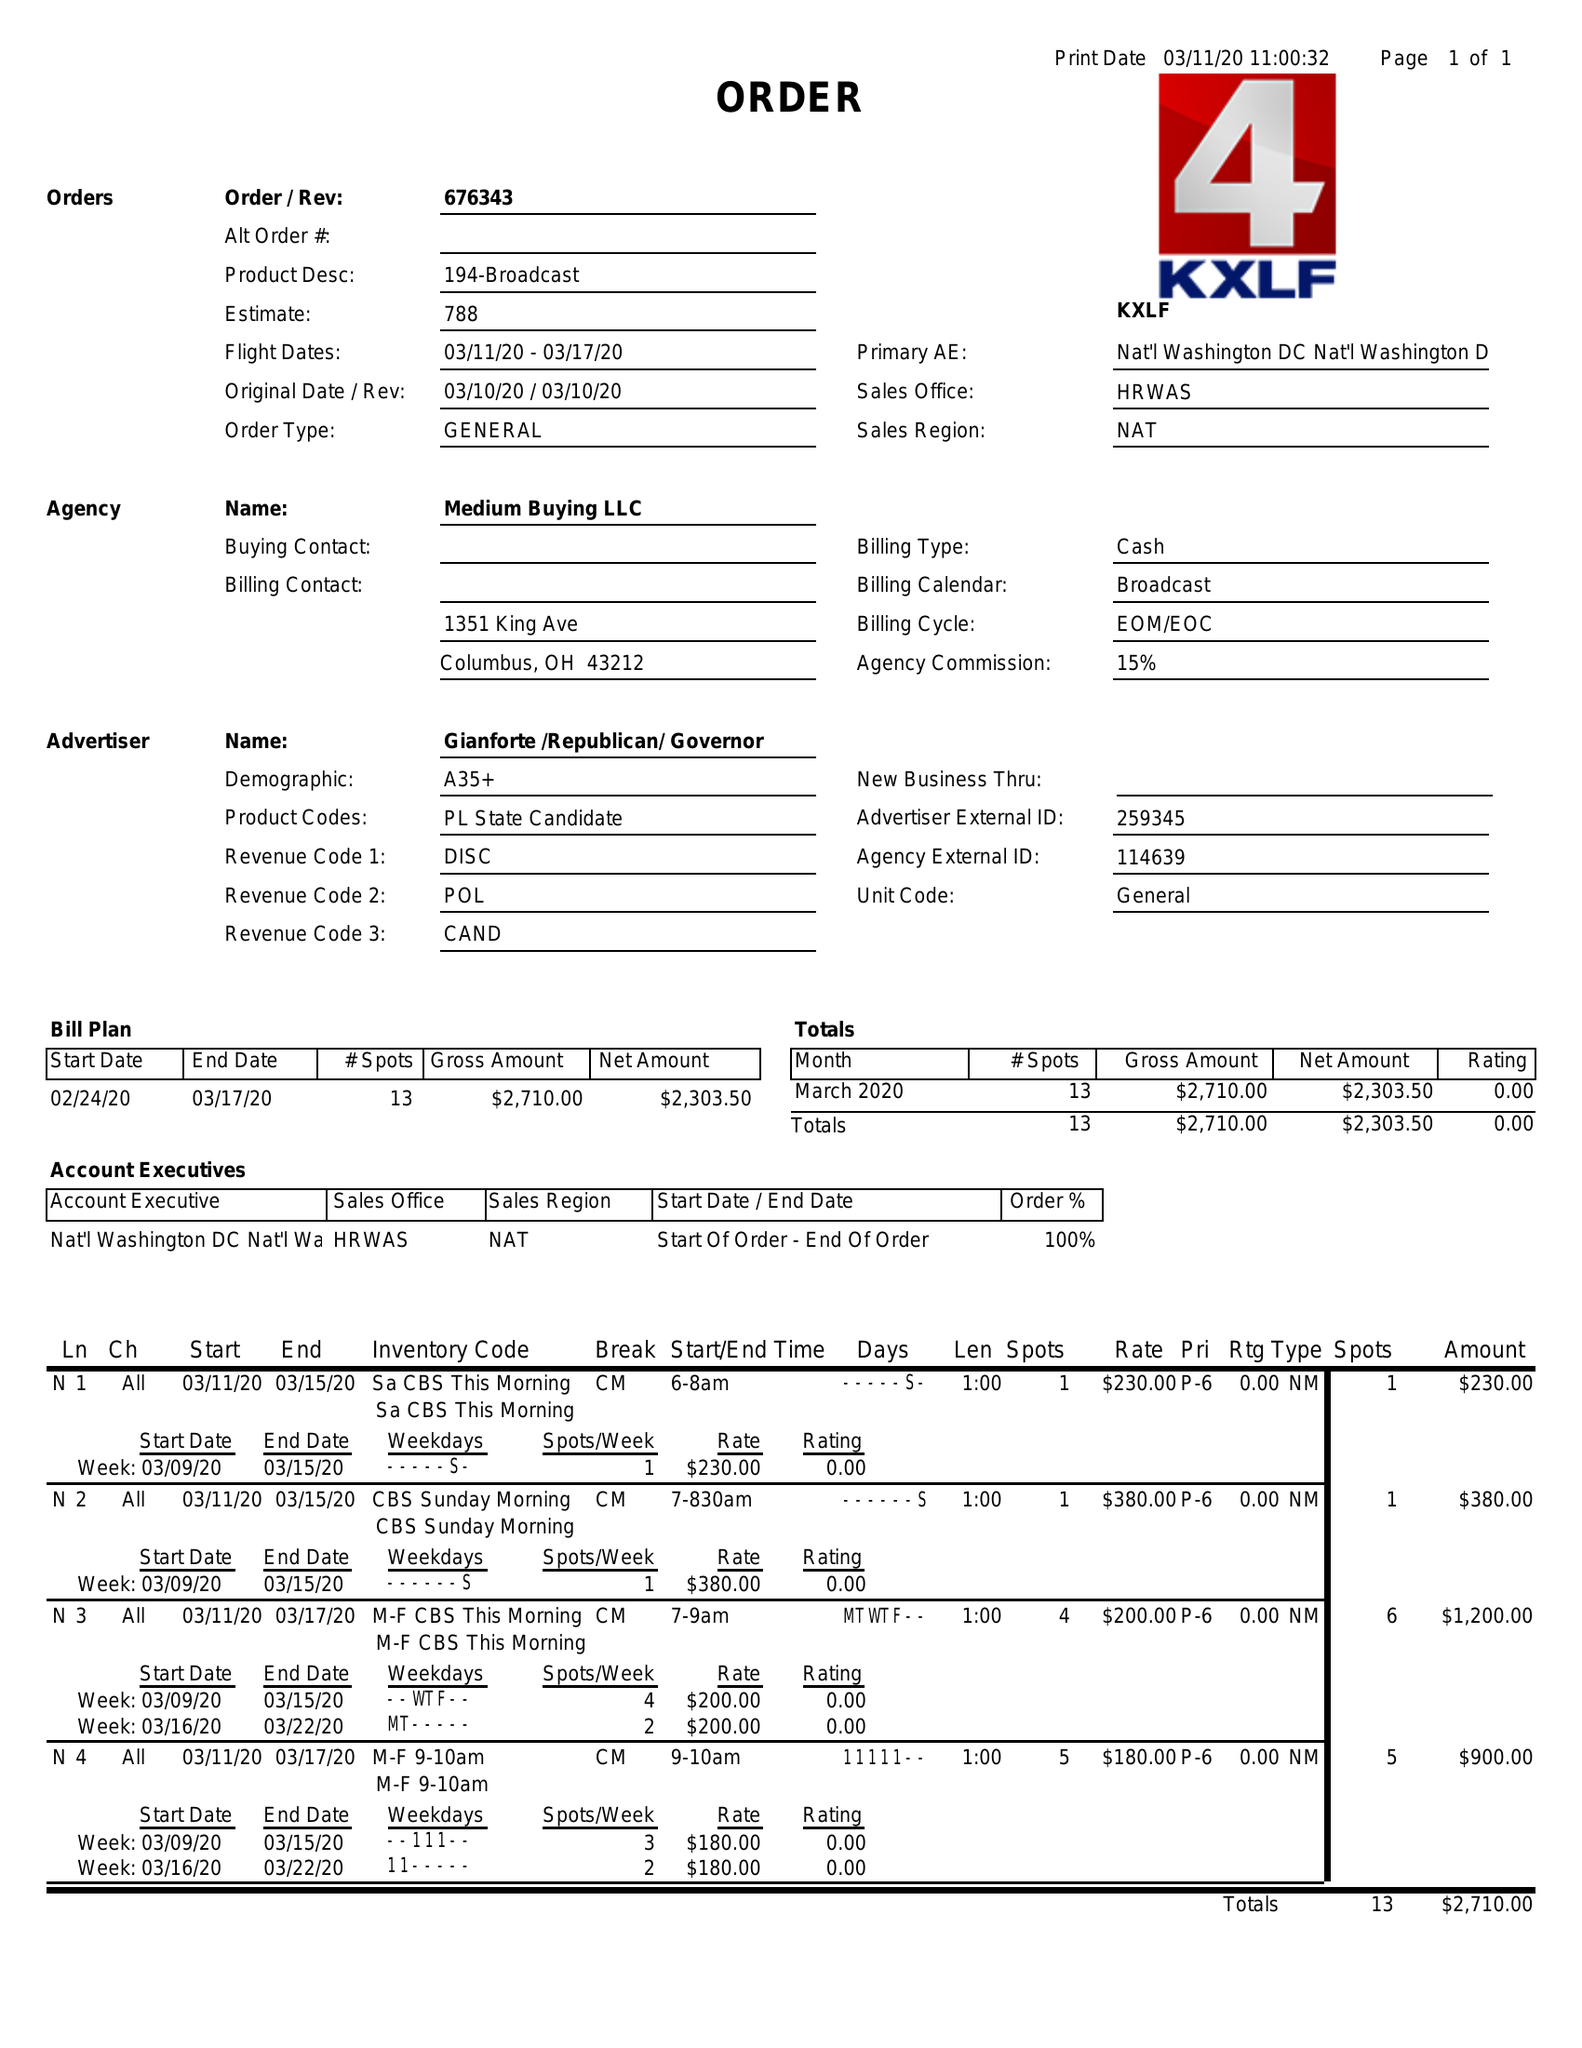What is the value for the flight_to?
Answer the question using a single word or phrase. 03/17/20 